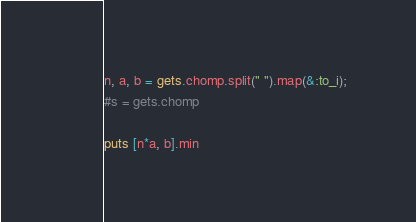Convert code to text. <code><loc_0><loc_0><loc_500><loc_500><_Ruby_>n, a, b = gets.chomp.split(" ").map(&:to_i);
#s = gets.chomp

puts [n*a, b].min</code> 